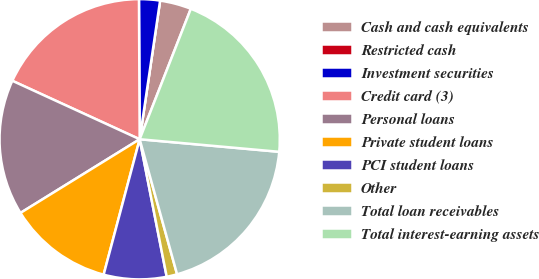Convert chart. <chart><loc_0><loc_0><loc_500><loc_500><pie_chart><fcel>Cash and cash equivalents<fcel>Restricted cash<fcel>Investment securities<fcel>Credit card (3)<fcel>Personal loans<fcel>Private student loans<fcel>PCI student loans<fcel>Other<fcel>Total loan receivables<fcel>Total interest-earning assets<nl><fcel>3.62%<fcel>0.0%<fcel>2.41%<fcel>18.07%<fcel>15.66%<fcel>12.05%<fcel>7.23%<fcel>1.21%<fcel>19.27%<fcel>20.48%<nl></chart> 